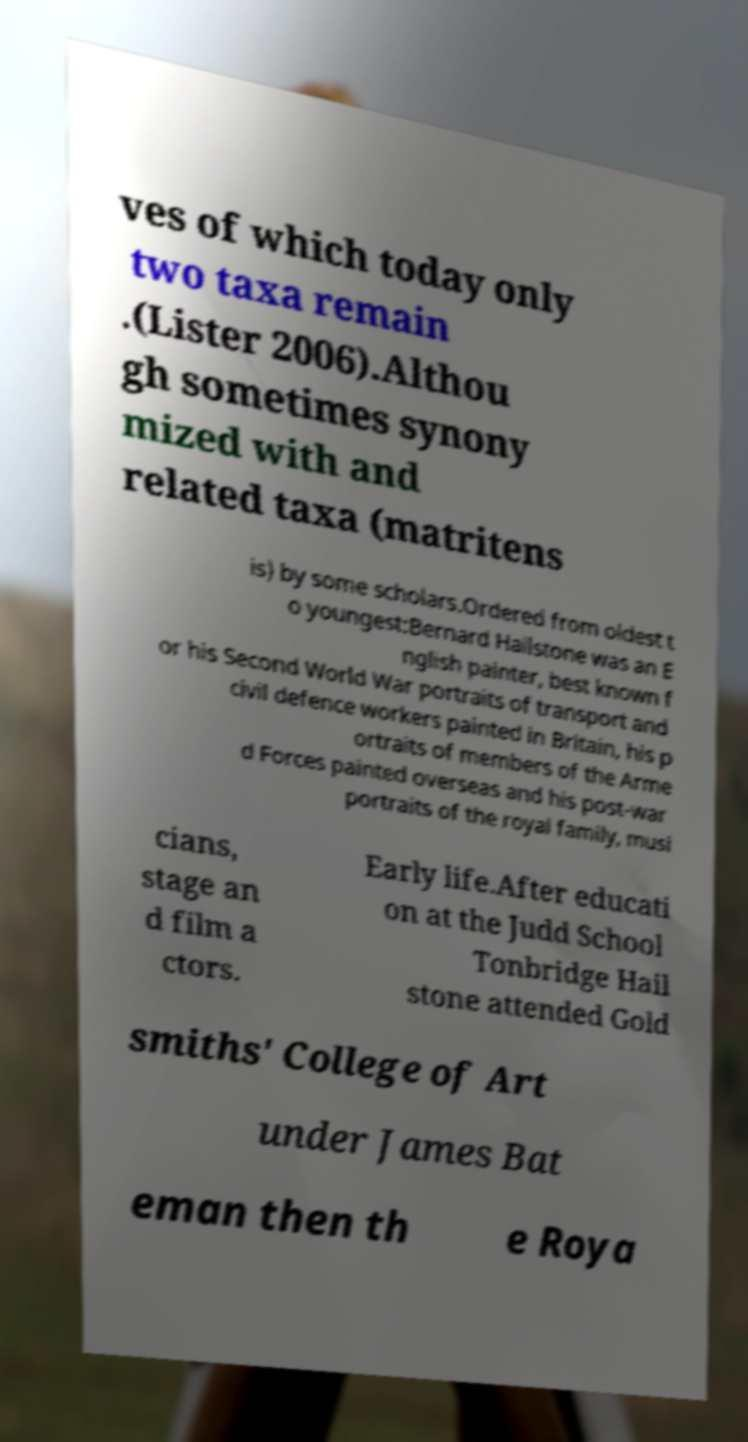I need the written content from this picture converted into text. Can you do that? ves of which today only two taxa remain .(Lister 2006).Althou gh sometimes synony mized with and related taxa (matritens is) by some scholars.Ordered from oldest t o youngest:Bernard Hailstone was an E nglish painter, best known f or his Second World War portraits of transport and civil defence workers painted in Britain, his p ortraits of members of the Arme d Forces painted overseas and his post-war portraits of the royal family, musi cians, stage an d film a ctors. Early life.After educati on at the Judd School Tonbridge Hail stone attended Gold smiths' College of Art under James Bat eman then th e Roya 